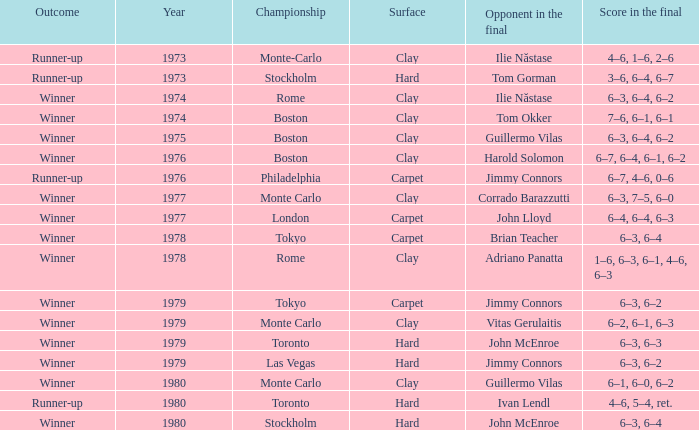Specify the surface of philadelphia. Carpet. 